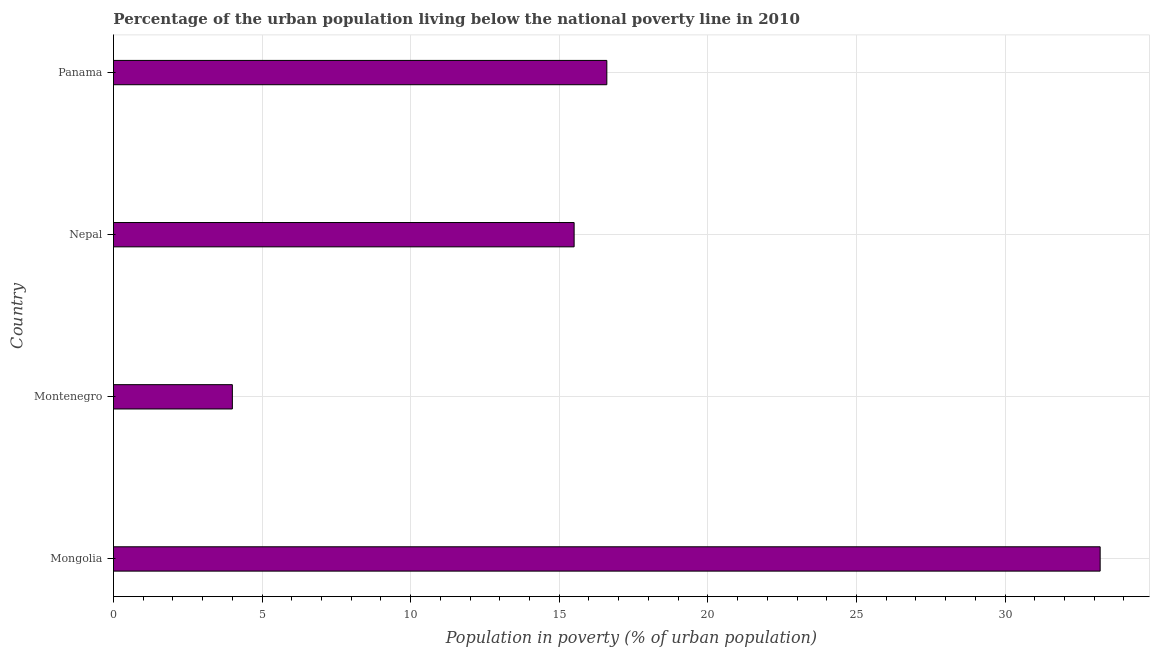What is the title of the graph?
Make the answer very short. Percentage of the urban population living below the national poverty line in 2010. What is the label or title of the X-axis?
Offer a terse response. Population in poverty (% of urban population). What is the label or title of the Y-axis?
Your response must be concise. Country. Across all countries, what is the maximum percentage of urban population living below poverty line?
Your response must be concise. 33.2. Across all countries, what is the minimum percentage of urban population living below poverty line?
Offer a very short reply. 4. In which country was the percentage of urban population living below poverty line maximum?
Give a very brief answer. Mongolia. In which country was the percentage of urban population living below poverty line minimum?
Provide a short and direct response. Montenegro. What is the sum of the percentage of urban population living below poverty line?
Your answer should be compact. 69.3. What is the difference between the percentage of urban population living below poverty line in Mongolia and Panama?
Provide a short and direct response. 16.6. What is the average percentage of urban population living below poverty line per country?
Make the answer very short. 17.32. What is the median percentage of urban population living below poverty line?
Offer a terse response. 16.05. What is the ratio of the percentage of urban population living below poverty line in Nepal to that in Panama?
Your response must be concise. 0.93. Is the difference between the percentage of urban population living below poverty line in Mongolia and Montenegro greater than the difference between any two countries?
Provide a succinct answer. Yes. What is the difference between the highest and the second highest percentage of urban population living below poverty line?
Give a very brief answer. 16.6. What is the difference between the highest and the lowest percentage of urban population living below poverty line?
Offer a very short reply. 29.2. Are all the bars in the graph horizontal?
Ensure brevity in your answer.  Yes. How many countries are there in the graph?
Make the answer very short. 4. What is the Population in poverty (% of urban population) in Mongolia?
Provide a succinct answer. 33.2. What is the difference between the Population in poverty (% of urban population) in Mongolia and Montenegro?
Offer a very short reply. 29.2. What is the difference between the Population in poverty (% of urban population) in Mongolia and Nepal?
Keep it short and to the point. 17.7. What is the difference between the Population in poverty (% of urban population) in Mongolia and Panama?
Provide a short and direct response. 16.6. What is the difference between the Population in poverty (% of urban population) in Montenegro and Nepal?
Offer a terse response. -11.5. What is the ratio of the Population in poverty (% of urban population) in Mongolia to that in Nepal?
Offer a terse response. 2.14. What is the ratio of the Population in poverty (% of urban population) in Mongolia to that in Panama?
Ensure brevity in your answer.  2. What is the ratio of the Population in poverty (% of urban population) in Montenegro to that in Nepal?
Your answer should be very brief. 0.26. What is the ratio of the Population in poverty (% of urban population) in Montenegro to that in Panama?
Keep it short and to the point. 0.24. What is the ratio of the Population in poverty (% of urban population) in Nepal to that in Panama?
Keep it short and to the point. 0.93. 